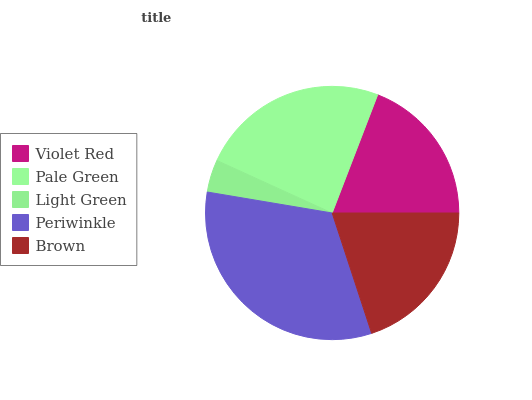Is Light Green the minimum?
Answer yes or no. Yes. Is Periwinkle the maximum?
Answer yes or no. Yes. Is Pale Green the minimum?
Answer yes or no. No. Is Pale Green the maximum?
Answer yes or no. No. Is Pale Green greater than Violet Red?
Answer yes or no. Yes. Is Violet Red less than Pale Green?
Answer yes or no. Yes. Is Violet Red greater than Pale Green?
Answer yes or no. No. Is Pale Green less than Violet Red?
Answer yes or no. No. Is Brown the high median?
Answer yes or no. Yes. Is Brown the low median?
Answer yes or no. Yes. Is Periwinkle the high median?
Answer yes or no. No. Is Violet Red the low median?
Answer yes or no. No. 